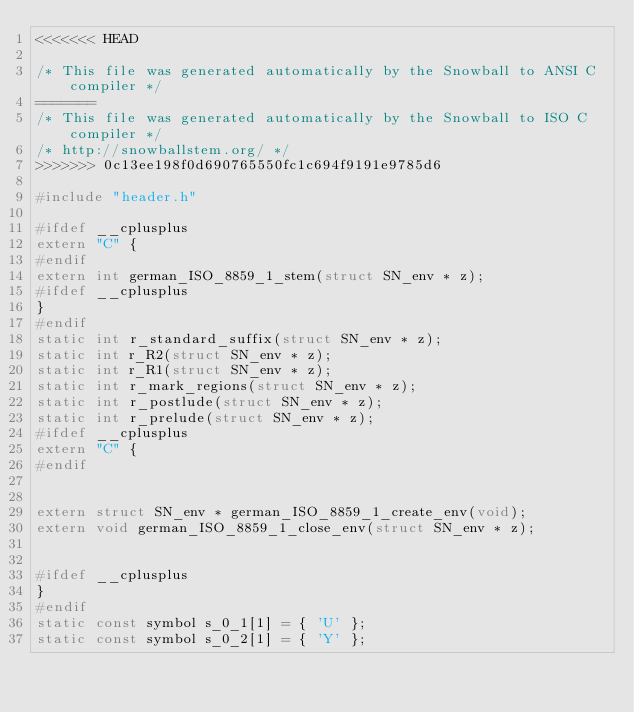<code> <loc_0><loc_0><loc_500><loc_500><_C_><<<<<<< HEAD

/* This file was generated automatically by the Snowball to ANSI C compiler */
=======
/* This file was generated automatically by the Snowball to ISO C compiler */
/* http://snowballstem.org/ */
>>>>>>> 0c13ee198f0d690765550fc1c694f9191e9785d6

#include "header.h"

#ifdef __cplusplus
extern "C" {
#endif
extern int german_ISO_8859_1_stem(struct SN_env * z);
#ifdef __cplusplus
}
#endif
static int r_standard_suffix(struct SN_env * z);
static int r_R2(struct SN_env * z);
static int r_R1(struct SN_env * z);
static int r_mark_regions(struct SN_env * z);
static int r_postlude(struct SN_env * z);
static int r_prelude(struct SN_env * z);
#ifdef __cplusplus
extern "C" {
#endif


extern struct SN_env * german_ISO_8859_1_create_env(void);
extern void german_ISO_8859_1_close_env(struct SN_env * z);


#ifdef __cplusplus
}
#endif
static const symbol s_0_1[1] = { 'U' };
static const symbol s_0_2[1] = { 'Y' };</code> 